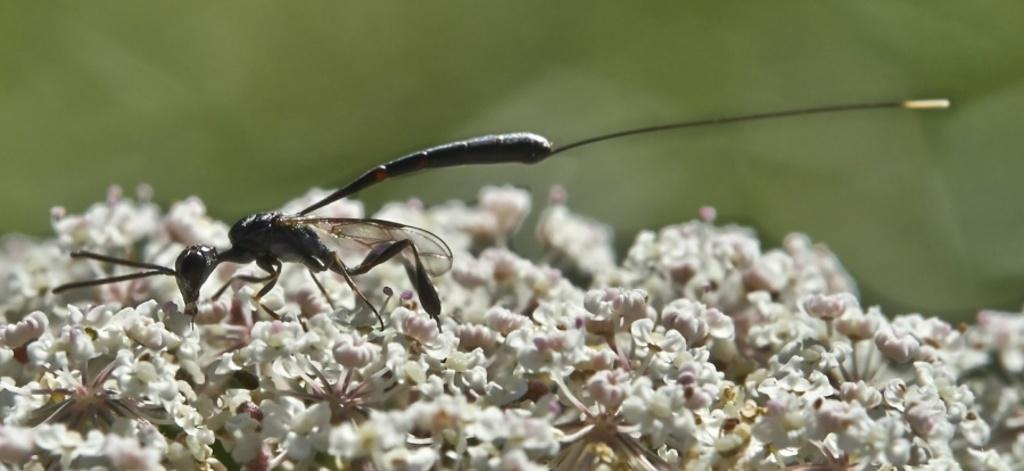What type of creature can be seen in the image? There is an insect present in the image. Where is the insect located in the image? The insect is on a flower. What type of wheel can be seen on the sofa in the image? There is no sofa or wheel present in the image. What is the insect doing on the top of the flower in the image? The insect is not necessarily doing anything specific on the top of the flower; it is simply present on the flower. 